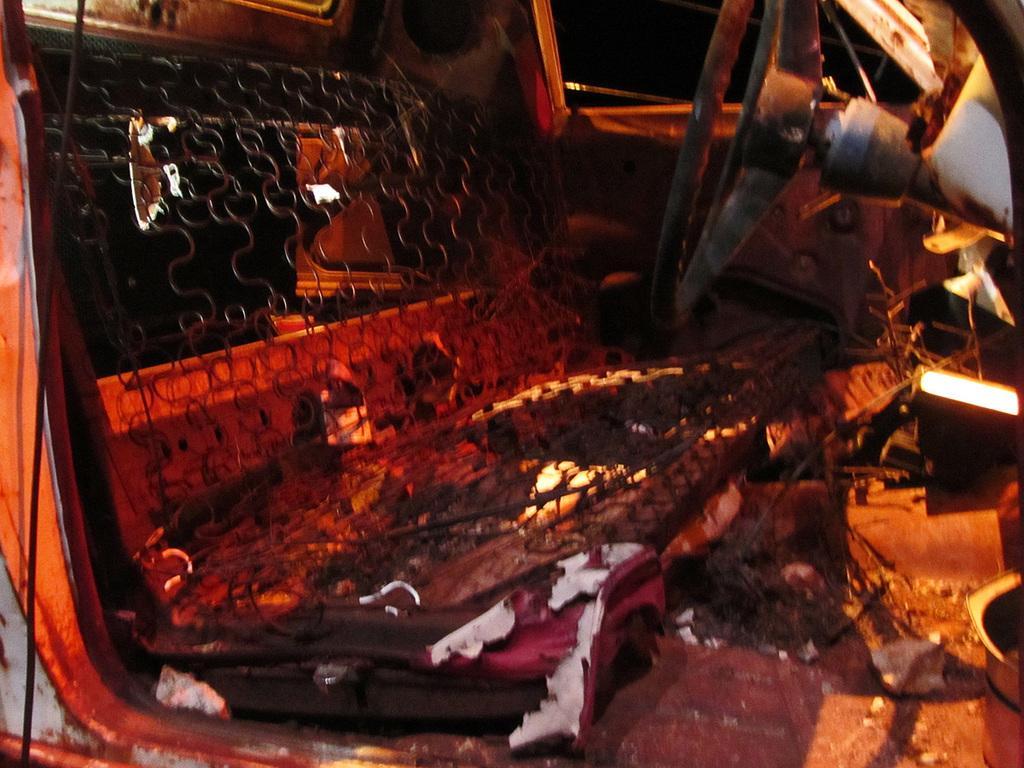In one or two sentences, can you explain what this image depicts? In this picture we can see an inside view of a vehicle, on the left side there is a seat, we can see a steering on the right side, there is a door in the background. 